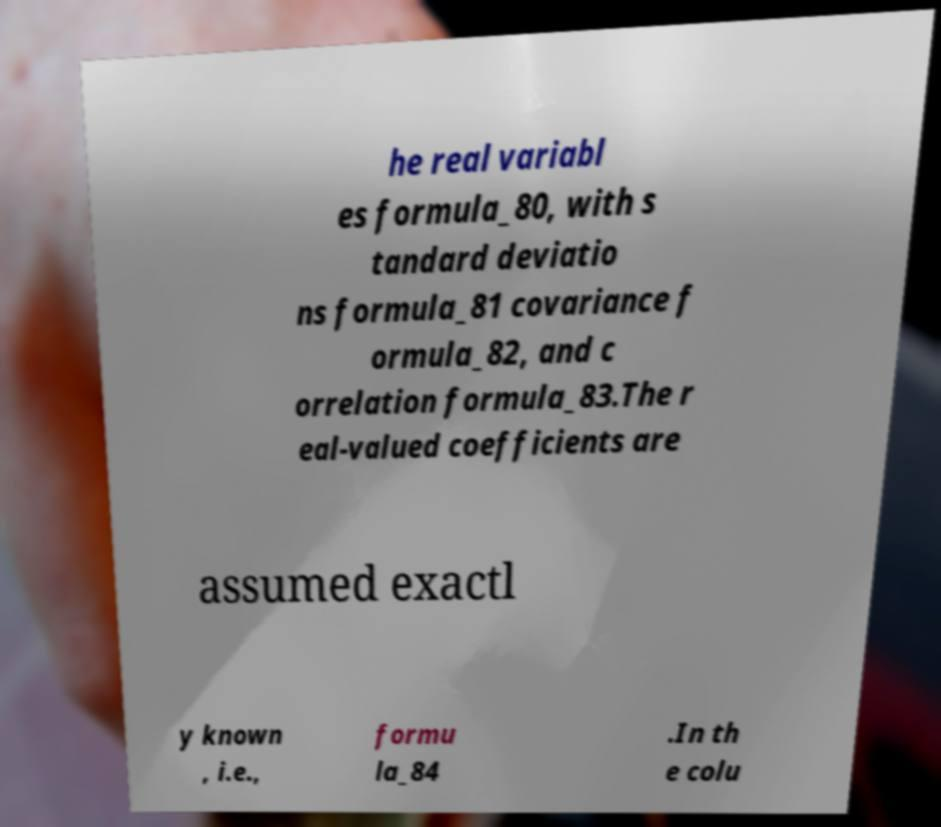I need the written content from this picture converted into text. Can you do that? he real variabl es formula_80, with s tandard deviatio ns formula_81 covariance f ormula_82, and c orrelation formula_83.The r eal-valued coefficients are assumed exactl y known , i.e., formu la_84 .In th e colu 